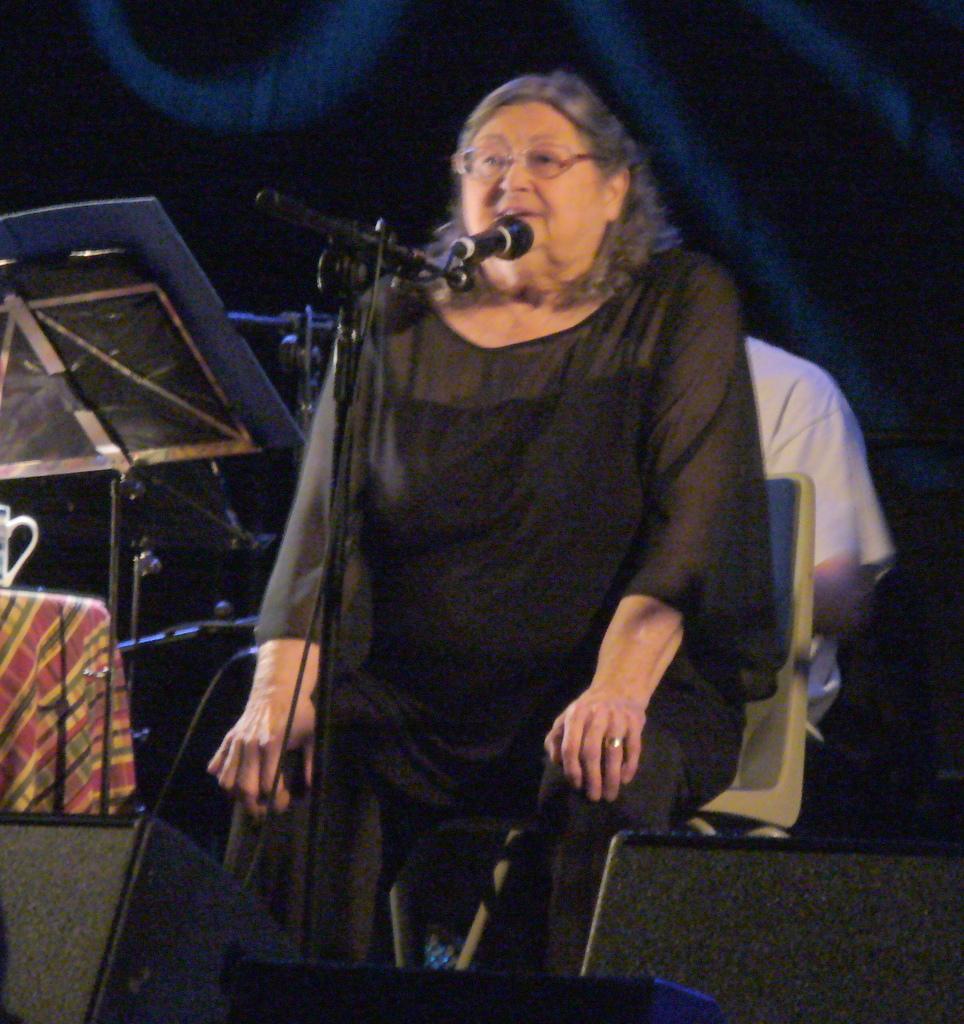In one or two sentences, can you explain what this image depicts? In this picture we can see a woman is sitting on a chair, there is a microphone in front of her, on the left side there is a music stand, we can see a table and another person in the background, there is a mug present on the table. 